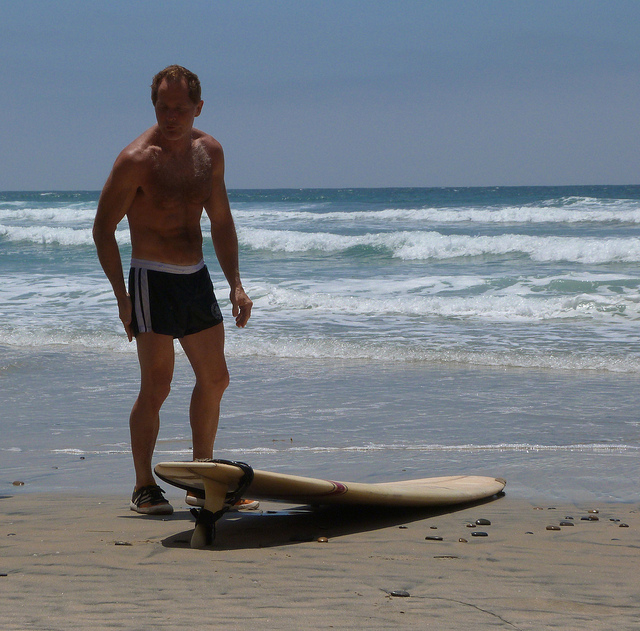Is the man performing any specific action? The man appears to be standing on the beach, looking down at the surfboard placed near his feet. His posture suggests that he may be contemplating or preparing for something related to the surfboard. 